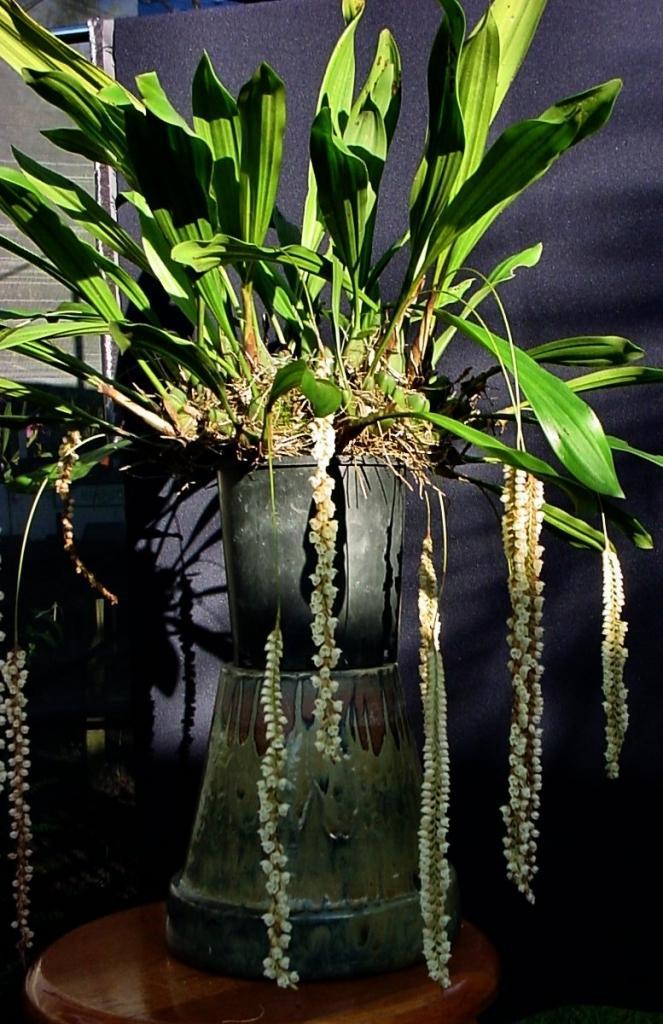Please provide a concise description of this image. In this image there is a plant pot kept on the table. In the background there is a curtain. 